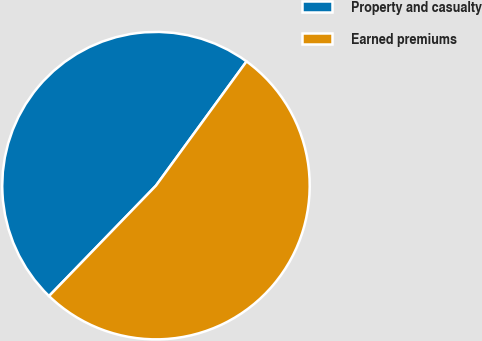<chart> <loc_0><loc_0><loc_500><loc_500><pie_chart><fcel>Property and casualty<fcel>Earned premiums<nl><fcel>47.78%<fcel>52.22%<nl></chart> 